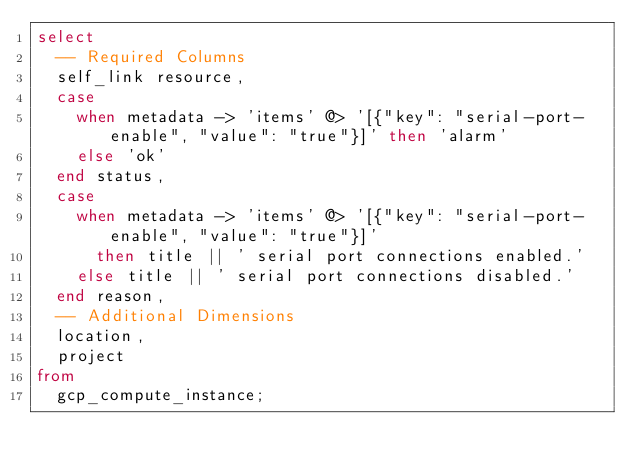Convert code to text. <code><loc_0><loc_0><loc_500><loc_500><_SQL_>select
  -- Required Columns
  self_link resource,
  case
    when metadata -> 'items' @> '[{"key": "serial-port-enable", "value": "true"}]' then 'alarm'
    else 'ok'
  end status,
  case
    when metadata -> 'items' @> '[{"key": "serial-port-enable", "value": "true"}]'
      then title || ' serial port connections enabled.'
    else title || ' serial port connections disabled.'
  end reason,
  -- Additional Dimensions
  location,
  project
from
  gcp_compute_instance;</code> 